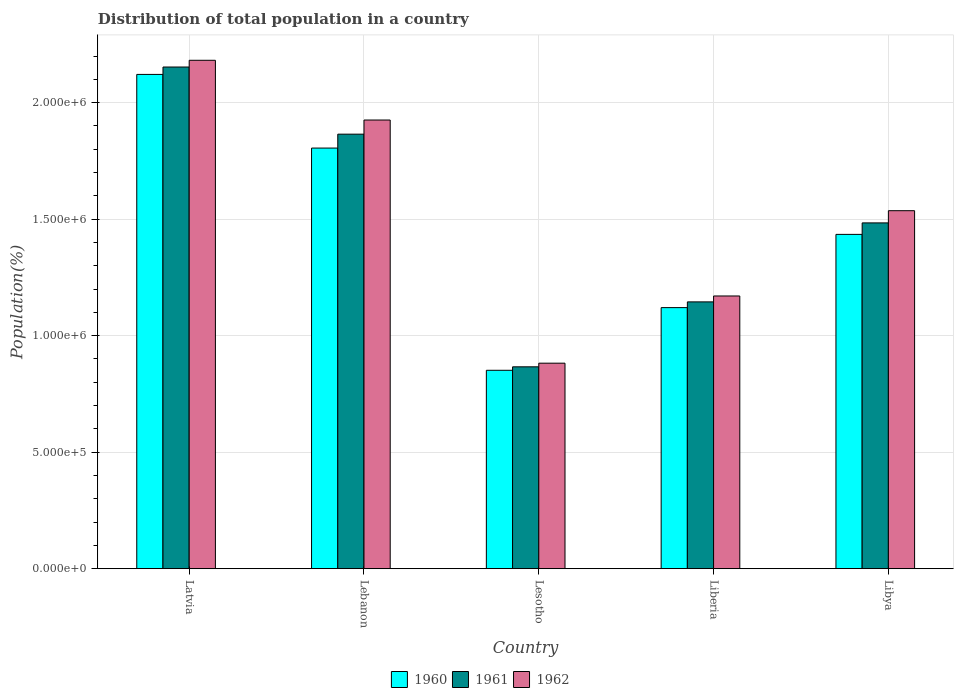How many different coloured bars are there?
Your response must be concise. 3. How many groups of bars are there?
Your answer should be very brief. 5. Are the number of bars per tick equal to the number of legend labels?
Make the answer very short. Yes. What is the label of the 5th group of bars from the left?
Offer a very short reply. Libya. What is the population of in 1962 in Libya?
Your answer should be very brief. 1.54e+06. Across all countries, what is the maximum population of in 1960?
Ensure brevity in your answer.  2.12e+06. Across all countries, what is the minimum population of in 1960?
Provide a succinct answer. 8.51e+05. In which country was the population of in 1961 maximum?
Make the answer very short. Latvia. In which country was the population of in 1961 minimum?
Give a very brief answer. Lesotho. What is the total population of in 1960 in the graph?
Offer a very short reply. 7.33e+06. What is the difference between the population of in 1961 in Lesotho and that in Libya?
Provide a short and direct response. -6.18e+05. What is the difference between the population of in 1962 in Lesotho and the population of in 1961 in Libya?
Your response must be concise. -6.02e+05. What is the average population of in 1960 per country?
Keep it short and to the point. 1.47e+06. What is the difference between the population of of/in 1961 and population of of/in 1960 in Liberia?
Ensure brevity in your answer.  2.46e+04. In how many countries, is the population of in 1962 greater than 1600000 %?
Offer a very short reply. 2. What is the ratio of the population of in 1962 in Latvia to that in Lesotho?
Your answer should be compact. 2.47. What is the difference between the highest and the second highest population of in 1960?
Offer a very short reply. -6.86e+05. What is the difference between the highest and the lowest population of in 1962?
Ensure brevity in your answer.  1.30e+06. In how many countries, is the population of in 1961 greater than the average population of in 1961 taken over all countries?
Your answer should be very brief. 2. Is the sum of the population of in 1960 in Lesotho and Liberia greater than the maximum population of in 1961 across all countries?
Keep it short and to the point. No. What does the 3rd bar from the right in Liberia represents?
Provide a succinct answer. 1960. Are all the bars in the graph horizontal?
Your answer should be compact. No. Are the values on the major ticks of Y-axis written in scientific E-notation?
Offer a very short reply. Yes. Does the graph contain any zero values?
Provide a succinct answer. No. How many legend labels are there?
Provide a short and direct response. 3. How are the legend labels stacked?
Make the answer very short. Horizontal. What is the title of the graph?
Your answer should be very brief. Distribution of total population in a country. What is the label or title of the Y-axis?
Offer a very short reply. Population(%). What is the Population(%) in 1960 in Latvia?
Offer a terse response. 2.12e+06. What is the Population(%) in 1961 in Latvia?
Offer a very short reply. 2.15e+06. What is the Population(%) in 1962 in Latvia?
Ensure brevity in your answer.  2.18e+06. What is the Population(%) of 1960 in Lebanon?
Your response must be concise. 1.80e+06. What is the Population(%) of 1961 in Lebanon?
Ensure brevity in your answer.  1.86e+06. What is the Population(%) of 1962 in Lebanon?
Your answer should be compact. 1.93e+06. What is the Population(%) in 1960 in Lesotho?
Ensure brevity in your answer.  8.51e+05. What is the Population(%) of 1961 in Lesotho?
Your response must be concise. 8.66e+05. What is the Population(%) in 1962 in Lesotho?
Your answer should be very brief. 8.82e+05. What is the Population(%) of 1960 in Liberia?
Keep it short and to the point. 1.12e+06. What is the Population(%) of 1961 in Liberia?
Keep it short and to the point. 1.14e+06. What is the Population(%) in 1962 in Liberia?
Offer a terse response. 1.17e+06. What is the Population(%) of 1960 in Libya?
Make the answer very short. 1.43e+06. What is the Population(%) in 1961 in Libya?
Ensure brevity in your answer.  1.48e+06. What is the Population(%) in 1962 in Libya?
Offer a very short reply. 1.54e+06. Across all countries, what is the maximum Population(%) in 1960?
Provide a short and direct response. 2.12e+06. Across all countries, what is the maximum Population(%) in 1961?
Your response must be concise. 2.15e+06. Across all countries, what is the maximum Population(%) of 1962?
Offer a terse response. 2.18e+06. Across all countries, what is the minimum Population(%) of 1960?
Keep it short and to the point. 8.51e+05. Across all countries, what is the minimum Population(%) of 1961?
Ensure brevity in your answer.  8.66e+05. Across all countries, what is the minimum Population(%) in 1962?
Provide a succinct answer. 8.82e+05. What is the total Population(%) in 1960 in the graph?
Give a very brief answer. 7.33e+06. What is the total Population(%) in 1961 in the graph?
Your answer should be very brief. 7.51e+06. What is the total Population(%) in 1962 in the graph?
Give a very brief answer. 7.70e+06. What is the difference between the Population(%) in 1960 in Latvia and that in Lebanon?
Your answer should be compact. 3.16e+05. What is the difference between the Population(%) of 1961 in Latvia and that in Lebanon?
Make the answer very short. 2.88e+05. What is the difference between the Population(%) in 1962 in Latvia and that in Lebanon?
Your answer should be compact. 2.56e+05. What is the difference between the Population(%) in 1960 in Latvia and that in Lesotho?
Your response must be concise. 1.27e+06. What is the difference between the Population(%) of 1961 in Latvia and that in Lesotho?
Provide a succinct answer. 1.29e+06. What is the difference between the Population(%) in 1962 in Latvia and that in Lesotho?
Your answer should be very brief. 1.30e+06. What is the difference between the Population(%) in 1960 in Latvia and that in Liberia?
Your answer should be very brief. 1.00e+06. What is the difference between the Population(%) of 1961 in Latvia and that in Liberia?
Give a very brief answer. 1.01e+06. What is the difference between the Population(%) of 1962 in Latvia and that in Liberia?
Your response must be concise. 1.01e+06. What is the difference between the Population(%) of 1960 in Latvia and that in Libya?
Offer a very short reply. 6.86e+05. What is the difference between the Population(%) of 1961 in Latvia and that in Libya?
Give a very brief answer. 6.69e+05. What is the difference between the Population(%) in 1962 in Latvia and that in Libya?
Offer a terse response. 6.45e+05. What is the difference between the Population(%) of 1960 in Lebanon and that in Lesotho?
Your answer should be very brief. 9.54e+05. What is the difference between the Population(%) in 1961 in Lebanon and that in Lesotho?
Provide a short and direct response. 9.98e+05. What is the difference between the Population(%) in 1962 in Lebanon and that in Lesotho?
Offer a very short reply. 1.04e+06. What is the difference between the Population(%) of 1960 in Lebanon and that in Liberia?
Offer a terse response. 6.85e+05. What is the difference between the Population(%) of 1961 in Lebanon and that in Liberia?
Your answer should be very brief. 7.20e+05. What is the difference between the Population(%) of 1962 in Lebanon and that in Liberia?
Ensure brevity in your answer.  7.55e+05. What is the difference between the Population(%) in 1960 in Lebanon and that in Libya?
Your answer should be compact. 3.70e+05. What is the difference between the Population(%) of 1961 in Lebanon and that in Libya?
Your response must be concise. 3.81e+05. What is the difference between the Population(%) in 1962 in Lebanon and that in Libya?
Your answer should be compact. 3.89e+05. What is the difference between the Population(%) of 1960 in Lesotho and that in Liberia?
Your answer should be compact. -2.69e+05. What is the difference between the Population(%) in 1961 in Lesotho and that in Liberia?
Provide a succinct answer. -2.79e+05. What is the difference between the Population(%) of 1962 in Lesotho and that in Liberia?
Offer a very short reply. -2.88e+05. What is the difference between the Population(%) of 1960 in Lesotho and that in Libya?
Offer a very short reply. -5.83e+05. What is the difference between the Population(%) of 1961 in Lesotho and that in Libya?
Your response must be concise. -6.18e+05. What is the difference between the Population(%) in 1962 in Lesotho and that in Libya?
Your response must be concise. -6.54e+05. What is the difference between the Population(%) of 1960 in Liberia and that in Libya?
Your response must be concise. -3.14e+05. What is the difference between the Population(%) of 1961 in Liberia and that in Libya?
Provide a short and direct response. -3.39e+05. What is the difference between the Population(%) in 1962 in Liberia and that in Libya?
Offer a very short reply. -3.66e+05. What is the difference between the Population(%) in 1960 in Latvia and the Population(%) in 1961 in Lebanon?
Keep it short and to the point. 2.56e+05. What is the difference between the Population(%) of 1960 in Latvia and the Population(%) of 1962 in Lebanon?
Ensure brevity in your answer.  1.96e+05. What is the difference between the Population(%) of 1961 in Latvia and the Population(%) of 1962 in Lebanon?
Give a very brief answer. 2.27e+05. What is the difference between the Population(%) in 1960 in Latvia and the Population(%) in 1961 in Lesotho?
Offer a very short reply. 1.25e+06. What is the difference between the Population(%) in 1960 in Latvia and the Population(%) in 1962 in Lesotho?
Your answer should be compact. 1.24e+06. What is the difference between the Population(%) of 1961 in Latvia and the Population(%) of 1962 in Lesotho?
Your answer should be very brief. 1.27e+06. What is the difference between the Population(%) of 1960 in Latvia and the Population(%) of 1961 in Liberia?
Ensure brevity in your answer.  9.76e+05. What is the difference between the Population(%) of 1960 in Latvia and the Population(%) of 1962 in Liberia?
Give a very brief answer. 9.51e+05. What is the difference between the Population(%) of 1961 in Latvia and the Population(%) of 1962 in Liberia?
Your response must be concise. 9.82e+05. What is the difference between the Population(%) of 1960 in Latvia and the Population(%) of 1961 in Libya?
Give a very brief answer. 6.37e+05. What is the difference between the Population(%) in 1960 in Latvia and the Population(%) in 1962 in Libya?
Offer a very short reply. 5.85e+05. What is the difference between the Population(%) in 1961 in Latvia and the Population(%) in 1962 in Libya?
Ensure brevity in your answer.  6.16e+05. What is the difference between the Population(%) of 1960 in Lebanon and the Population(%) of 1961 in Lesotho?
Provide a short and direct response. 9.39e+05. What is the difference between the Population(%) of 1960 in Lebanon and the Population(%) of 1962 in Lesotho?
Offer a terse response. 9.23e+05. What is the difference between the Population(%) in 1961 in Lebanon and the Population(%) in 1962 in Lesotho?
Offer a terse response. 9.83e+05. What is the difference between the Population(%) of 1960 in Lebanon and the Population(%) of 1961 in Liberia?
Your response must be concise. 6.60e+05. What is the difference between the Population(%) of 1960 in Lebanon and the Population(%) of 1962 in Liberia?
Offer a very short reply. 6.35e+05. What is the difference between the Population(%) in 1961 in Lebanon and the Population(%) in 1962 in Liberia?
Your response must be concise. 6.94e+05. What is the difference between the Population(%) in 1960 in Lebanon and the Population(%) in 1961 in Libya?
Ensure brevity in your answer.  3.21e+05. What is the difference between the Population(%) of 1960 in Lebanon and the Population(%) of 1962 in Libya?
Offer a terse response. 2.69e+05. What is the difference between the Population(%) of 1961 in Lebanon and the Population(%) of 1962 in Libya?
Keep it short and to the point. 3.28e+05. What is the difference between the Population(%) of 1960 in Lesotho and the Population(%) of 1961 in Liberia?
Provide a short and direct response. -2.93e+05. What is the difference between the Population(%) of 1960 in Lesotho and the Population(%) of 1962 in Liberia?
Offer a terse response. -3.19e+05. What is the difference between the Population(%) in 1961 in Lesotho and the Population(%) in 1962 in Liberia?
Give a very brief answer. -3.04e+05. What is the difference between the Population(%) of 1960 in Lesotho and the Population(%) of 1961 in Libya?
Your response must be concise. -6.32e+05. What is the difference between the Population(%) in 1960 in Lesotho and the Population(%) in 1962 in Libya?
Your answer should be very brief. -6.85e+05. What is the difference between the Population(%) in 1961 in Lesotho and the Population(%) in 1962 in Libya?
Provide a succinct answer. -6.70e+05. What is the difference between the Population(%) of 1960 in Liberia and the Population(%) of 1961 in Libya?
Provide a succinct answer. -3.64e+05. What is the difference between the Population(%) of 1960 in Liberia and the Population(%) of 1962 in Libya?
Your answer should be very brief. -4.16e+05. What is the difference between the Population(%) in 1961 in Liberia and the Population(%) in 1962 in Libya?
Provide a succinct answer. -3.91e+05. What is the average Population(%) in 1960 per country?
Provide a succinct answer. 1.47e+06. What is the average Population(%) of 1961 per country?
Provide a succinct answer. 1.50e+06. What is the average Population(%) of 1962 per country?
Offer a very short reply. 1.54e+06. What is the difference between the Population(%) of 1960 and Population(%) of 1961 in Latvia?
Ensure brevity in your answer.  -3.17e+04. What is the difference between the Population(%) of 1960 and Population(%) of 1962 in Latvia?
Provide a short and direct response. -6.06e+04. What is the difference between the Population(%) in 1961 and Population(%) in 1962 in Latvia?
Keep it short and to the point. -2.89e+04. What is the difference between the Population(%) of 1960 and Population(%) of 1961 in Lebanon?
Offer a terse response. -5.97e+04. What is the difference between the Population(%) in 1960 and Population(%) in 1962 in Lebanon?
Keep it short and to the point. -1.20e+05. What is the difference between the Population(%) of 1961 and Population(%) of 1962 in Lebanon?
Provide a succinct answer. -6.07e+04. What is the difference between the Population(%) of 1960 and Population(%) of 1961 in Lesotho?
Offer a very short reply. -1.48e+04. What is the difference between the Population(%) of 1960 and Population(%) of 1962 in Lesotho?
Offer a terse response. -3.05e+04. What is the difference between the Population(%) in 1961 and Population(%) in 1962 in Lesotho?
Your answer should be very brief. -1.57e+04. What is the difference between the Population(%) in 1960 and Population(%) in 1961 in Liberia?
Make the answer very short. -2.46e+04. What is the difference between the Population(%) in 1960 and Population(%) in 1962 in Liberia?
Keep it short and to the point. -5.00e+04. What is the difference between the Population(%) in 1961 and Population(%) in 1962 in Liberia?
Provide a short and direct response. -2.54e+04. What is the difference between the Population(%) of 1960 and Population(%) of 1961 in Libya?
Give a very brief answer. -4.93e+04. What is the difference between the Population(%) of 1960 and Population(%) of 1962 in Libya?
Provide a short and direct response. -1.02e+05. What is the difference between the Population(%) of 1961 and Population(%) of 1962 in Libya?
Your answer should be compact. -5.23e+04. What is the ratio of the Population(%) in 1960 in Latvia to that in Lebanon?
Your response must be concise. 1.18. What is the ratio of the Population(%) in 1961 in Latvia to that in Lebanon?
Provide a short and direct response. 1.15. What is the ratio of the Population(%) of 1962 in Latvia to that in Lebanon?
Your answer should be compact. 1.13. What is the ratio of the Population(%) of 1960 in Latvia to that in Lesotho?
Offer a terse response. 2.49. What is the ratio of the Population(%) in 1961 in Latvia to that in Lesotho?
Your response must be concise. 2.48. What is the ratio of the Population(%) in 1962 in Latvia to that in Lesotho?
Provide a succinct answer. 2.47. What is the ratio of the Population(%) of 1960 in Latvia to that in Liberia?
Your response must be concise. 1.89. What is the ratio of the Population(%) of 1961 in Latvia to that in Liberia?
Your answer should be compact. 1.88. What is the ratio of the Population(%) in 1962 in Latvia to that in Liberia?
Your answer should be very brief. 1.86. What is the ratio of the Population(%) of 1960 in Latvia to that in Libya?
Give a very brief answer. 1.48. What is the ratio of the Population(%) in 1961 in Latvia to that in Libya?
Keep it short and to the point. 1.45. What is the ratio of the Population(%) in 1962 in Latvia to that in Libya?
Give a very brief answer. 1.42. What is the ratio of the Population(%) in 1960 in Lebanon to that in Lesotho?
Make the answer very short. 2.12. What is the ratio of the Population(%) of 1961 in Lebanon to that in Lesotho?
Offer a very short reply. 2.15. What is the ratio of the Population(%) in 1962 in Lebanon to that in Lesotho?
Give a very brief answer. 2.18. What is the ratio of the Population(%) of 1960 in Lebanon to that in Liberia?
Provide a succinct answer. 1.61. What is the ratio of the Population(%) in 1961 in Lebanon to that in Liberia?
Keep it short and to the point. 1.63. What is the ratio of the Population(%) of 1962 in Lebanon to that in Liberia?
Provide a short and direct response. 1.65. What is the ratio of the Population(%) of 1960 in Lebanon to that in Libya?
Keep it short and to the point. 1.26. What is the ratio of the Population(%) of 1961 in Lebanon to that in Libya?
Offer a very short reply. 1.26. What is the ratio of the Population(%) in 1962 in Lebanon to that in Libya?
Keep it short and to the point. 1.25. What is the ratio of the Population(%) in 1960 in Lesotho to that in Liberia?
Provide a short and direct response. 0.76. What is the ratio of the Population(%) of 1961 in Lesotho to that in Liberia?
Ensure brevity in your answer.  0.76. What is the ratio of the Population(%) of 1962 in Lesotho to that in Liberia?
Make the answer very short. 0.75. What is the ratio of the Population(%) of 1960 in Lesotho to that in Libya?
Your answer should be compact. 0.59. What is the ratio of the Population(%) in 1961 in Lesotho to that in Libya?
Your answer should be compact. 0.58. What is the ratio of the Population(%) in 1962 in Lesotho to that in Libya?
Offer a very short reply. 0.57. What is the ratio of the Population(%) in 1960 in Liberia to that in Libya?
Offer a terse response. 0.78. What is the ratio of the Population(%) in 1961 in Liberia to that in Libya?
Your response must be concise. 0.77. What is the ratio of the Population(%) of 1962 in Liberia to that in Libya?
Your response must be concise. 0.76. What is the difference between the highest and the second highest Population(%) of 1960?
Your response must be concise. 3.16e+05. What is the difference between the highest and the second highest Population(%) in 1961?
Offer a terse response. 2.88e+05. What is the difference between the highest and the second highest Population(%) in 1962?
Give a very brief answer. 2.56e+05. What is the difference between the highest and the lowest Population(%) of 1960?
Keep it short and to the point. 1.27e+06. What is the difference between the highest and the lowest Population(%) of 1961?
Ensure brevity in your answer.  1.29e+06. What is the difference between the highest and the lowest Population(%) of 1962?
Keep it short and to the point. 1.30e+06. 